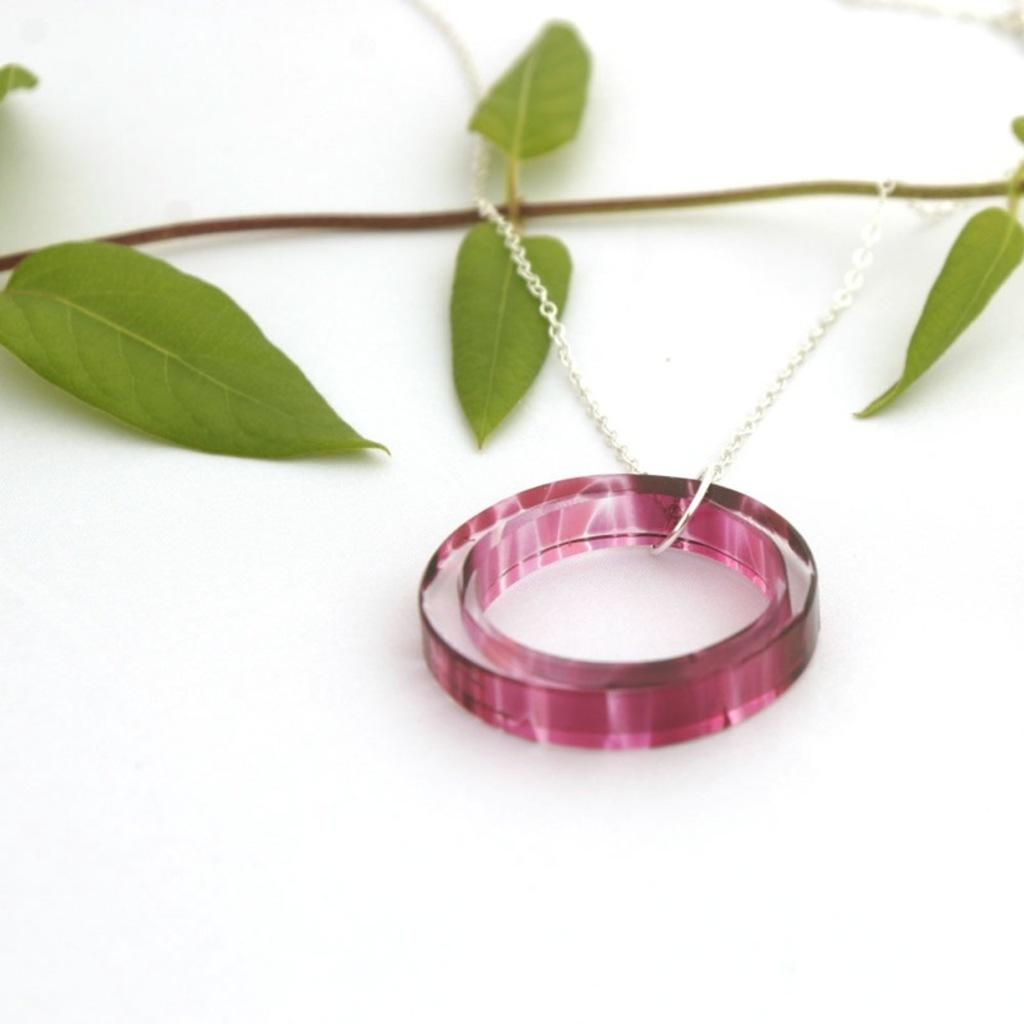What is the main subject on the white surface in the image? There is a stem with leaves on a white surface. What other objects can be seen on the white surface? There is a chain and a ring on the white surface. What type of animal is present on the white surface in the image? There are no animals present on the white surface in the image. 